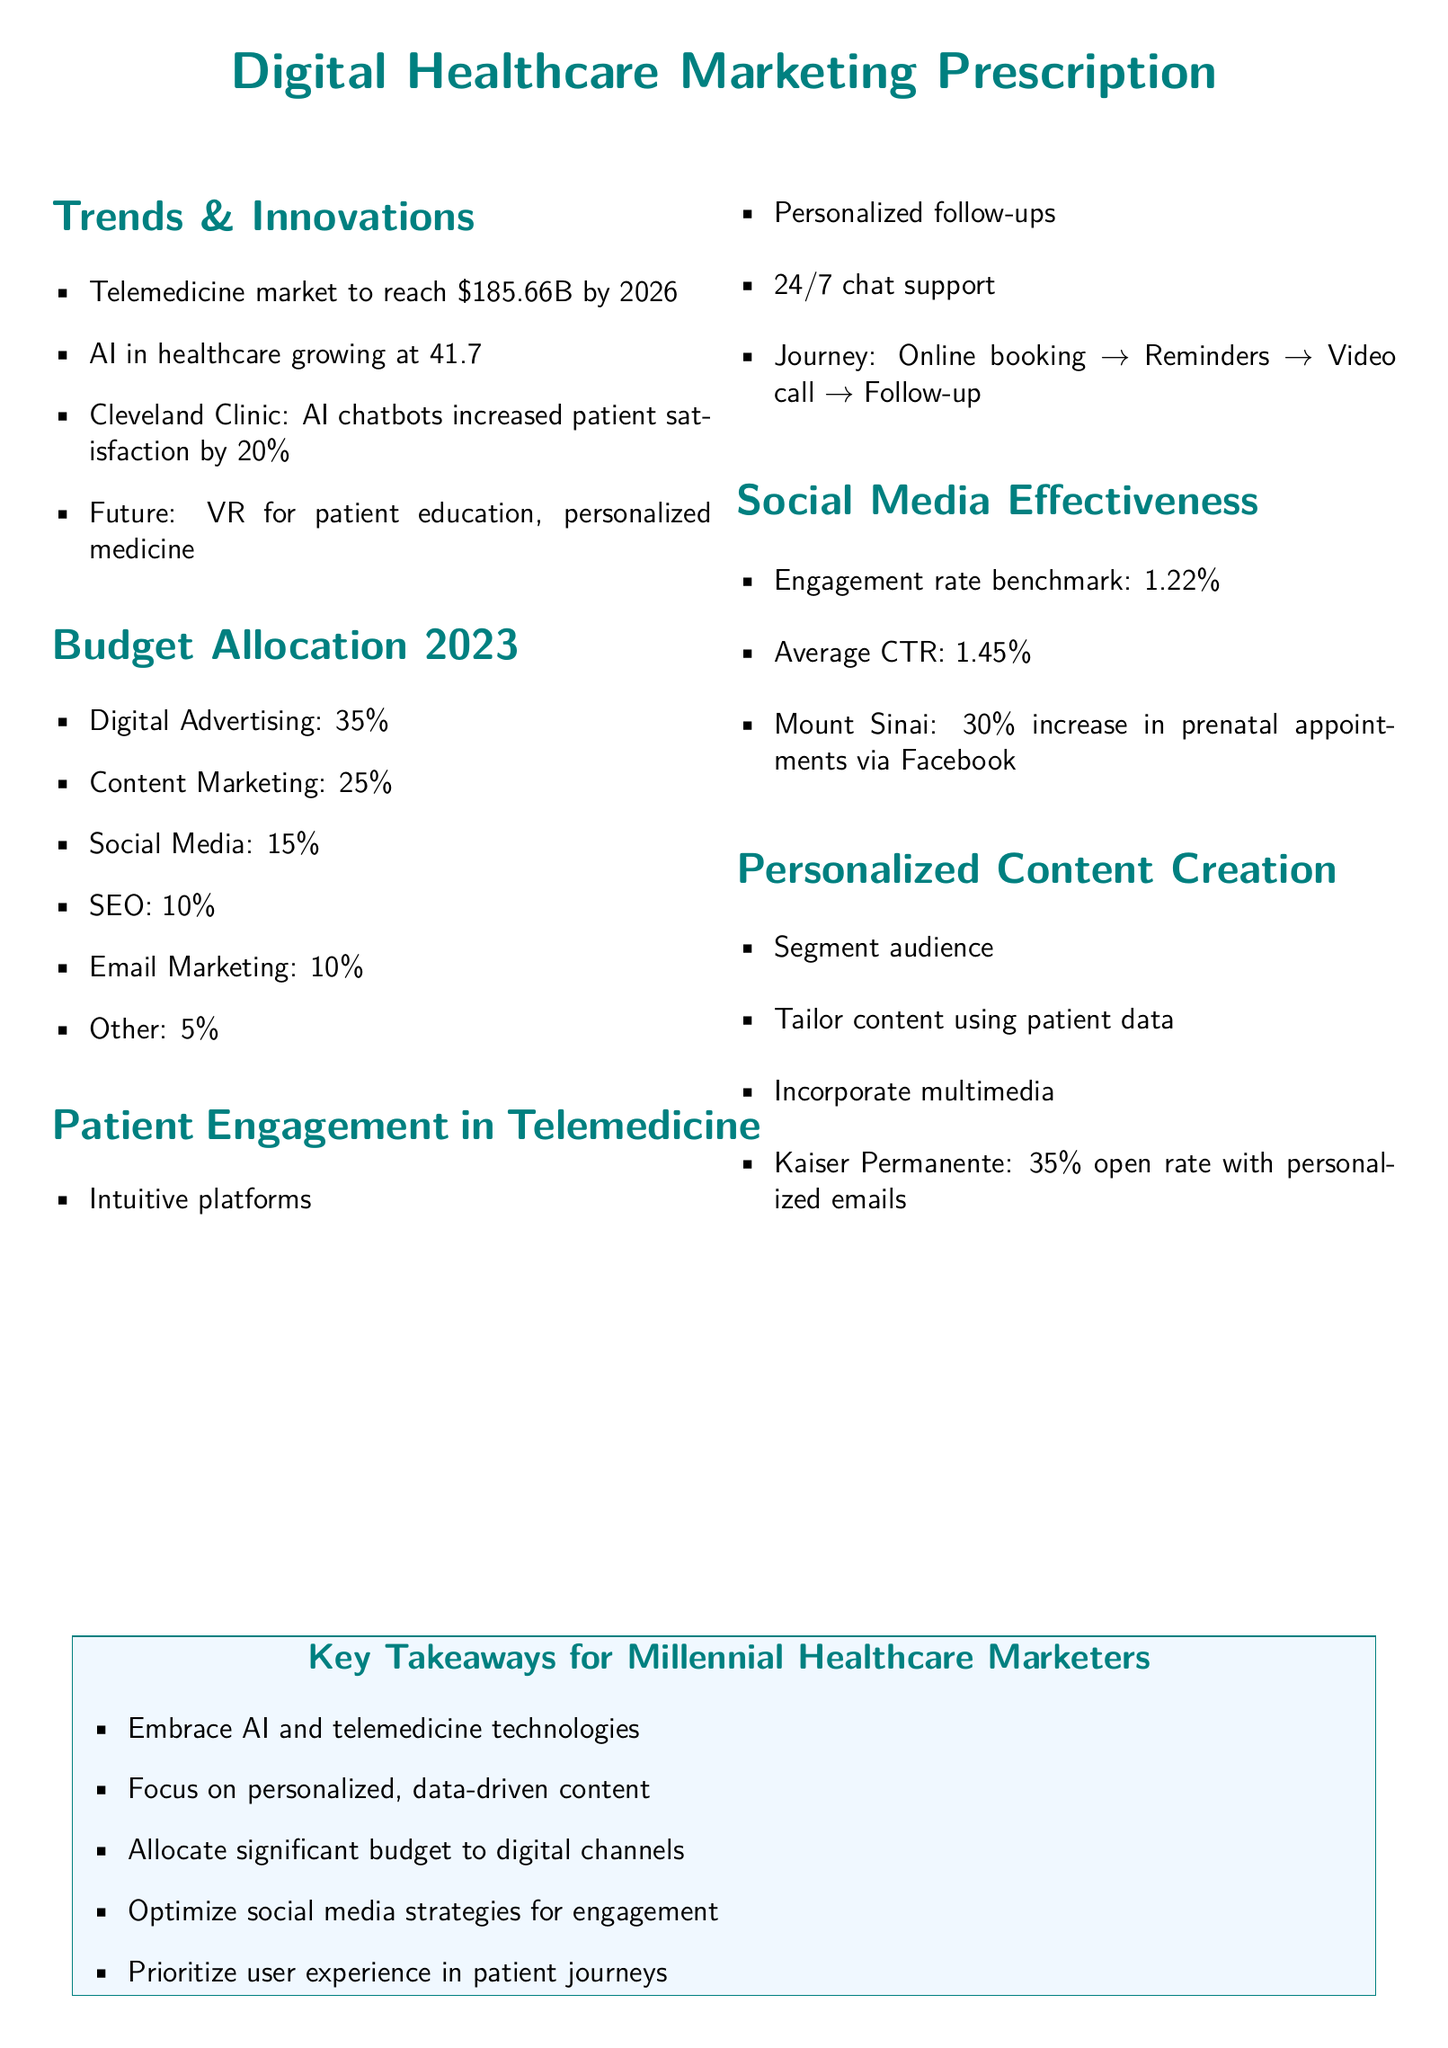What is the projected telemedicine market size by 2026? The document states that the telemedicine market is expected to reach a size of $185.66 billion by 2026.
Answer: $185.66B What is the annual growth rate of AI in healthcare? The document mentions that AI in healthcare is growing at a CAGR of 41.7% from 2021 to 2027.
Answer: 41.7% Which hospital used AI chatbots to increase patient satisfaction? According to the document, Cleveland Clinic used AI chatbots that increased patient satisfaction.
Answer: Cleveland Clinic What percentage of the budget should be allocated to digital advertising in 2023? The document specifies that 35% of the budget should be allocated to digital advertising.
Answer: 35% What is the engagement rate benchmark mentioned in social media effectiveness? The engagement rate benchmark noted in the document is 1.22%.
Answer: 1.22% Which healthcare organization achieved a 30% increase in prenatal appointments through social media? The document reports that Mount Sinai achieved a 30% increase in prenatal appointments via Facebook.
Answer: Mount Sinai What is one of the key takeaways for millennial healthcare marketers? The document highlights that one key takeaway is to embrace AI and telemedicine technologies.
Answer: Embrace AI and telemedicine technologies What is the average click-through rate (CTR) according to the document? The document states that the average CTR is 1.45%.
Answer: 1.45% What is one strategy for enhancing patient engagement using telemedicine? The document mentions that personalized follow-ups can enhance patient engagement using telemedicine.
Answer: Personalized follow-ups 